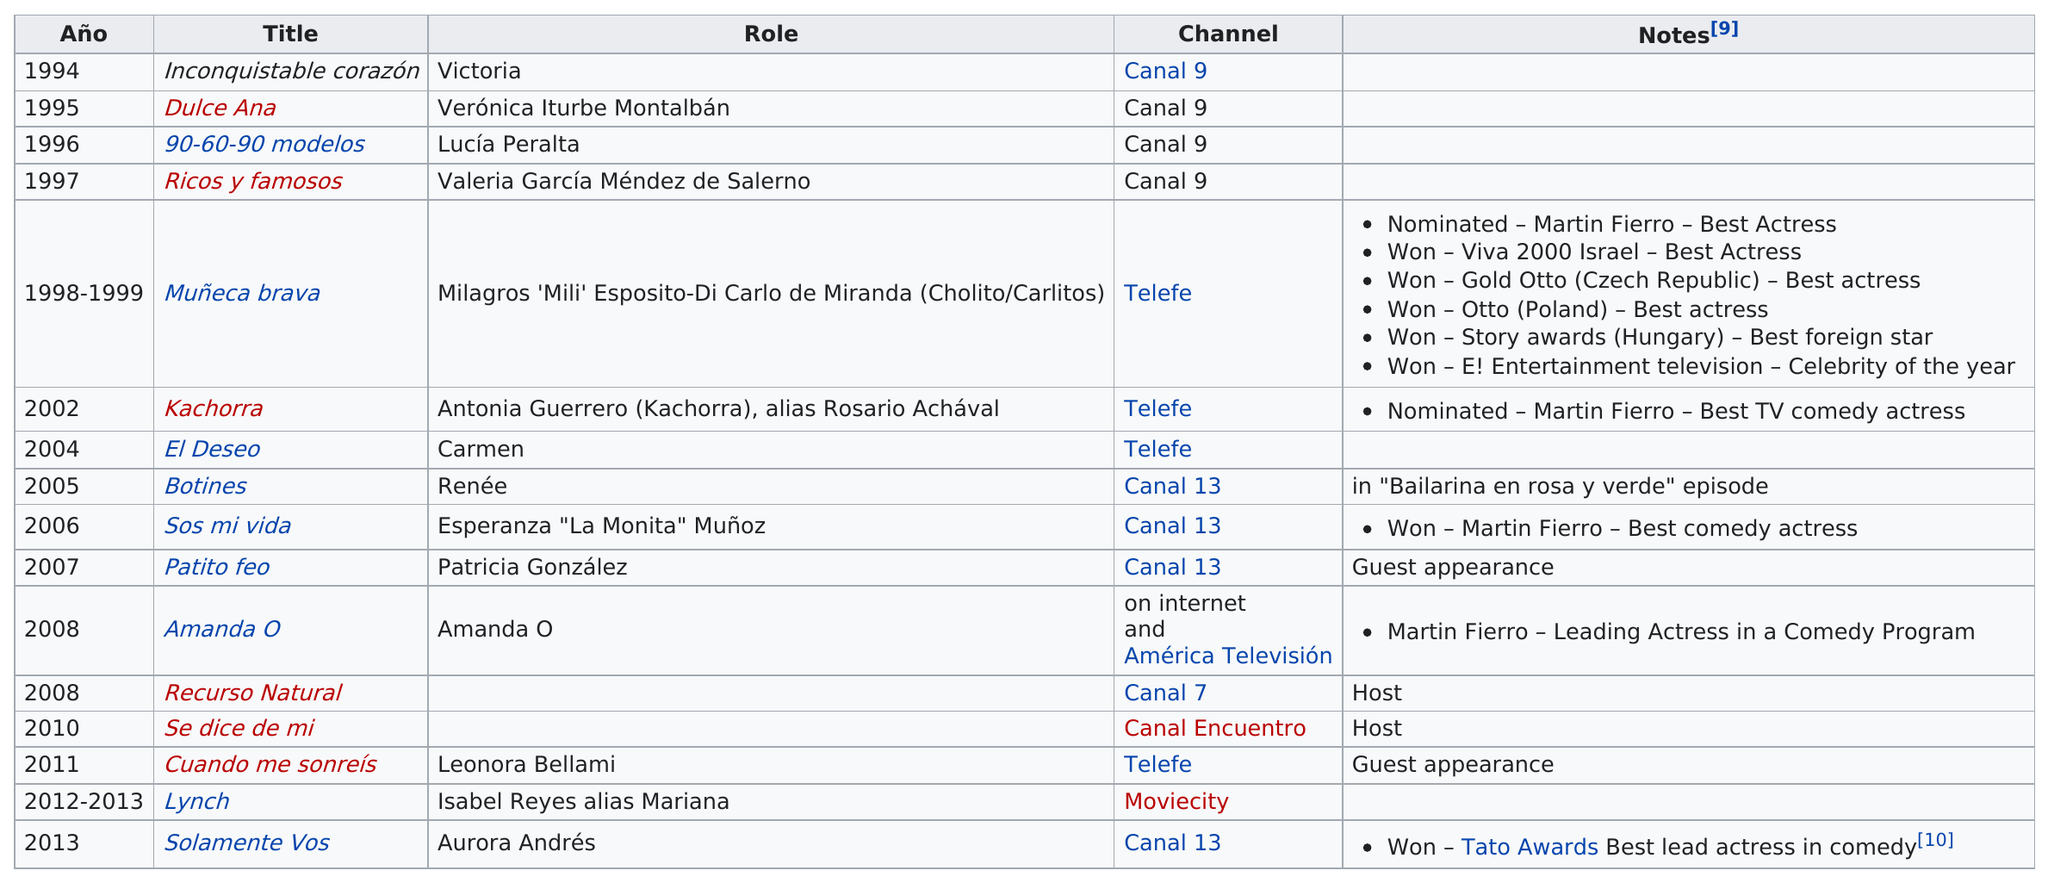Draw attention to some important aspects in this diagram. Natalia Oriero was a cast member on the show "Lynch" during the years 2012 and 2013. She won five awards for her role in Money Heist. Natalia Orío's first TV role was in 1994. The actress won a story award and a viva 2000 Israel award for her role in the TV show "Muneca brava. In 2008, Natalia Oreiro hosted a show called 'Recurso Natural.' 